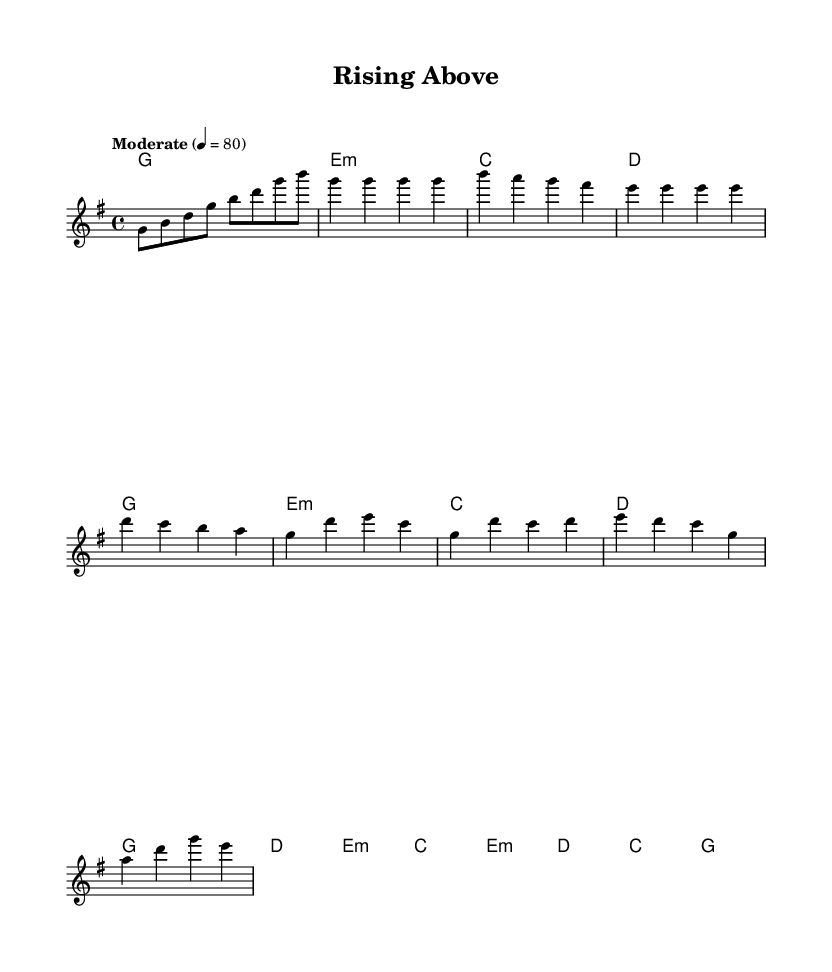What is the key signature of this music? The key signature appears at the beginning of the staff, showing a single sharp, which indicates that the key is G major.
Answer: G major What is the time signature of this piece? The time signature is located at the beginning of the score, represented by the numbers 4 over 4, indicating four beats per measure.
Answer: 4/4 What is the tempo marking given in the score? The tempo marking is noted as "Moderate", which indicates a moderate pace, and the specific tempo is set at 80 beats per minute.
Answer: Moderate 80 How many measures are in the verse? By counting the number of vertical lines (bar lines) in the verse section, there are four measures present in this part of the music.
Answer: 4 Which part of the song features the lyrics "I'm rising above the pain"? The lyrics "I'm rising above the pain" are found in the chorus section, which comes immediately after the verse in the structure.
Answer: Chorus What is the primary theme reflected in the lyrics? The lyrics discuss resilience and overcoming hardships, emphasizing the determination to persevere despite challenges.
Answer: Resilience 